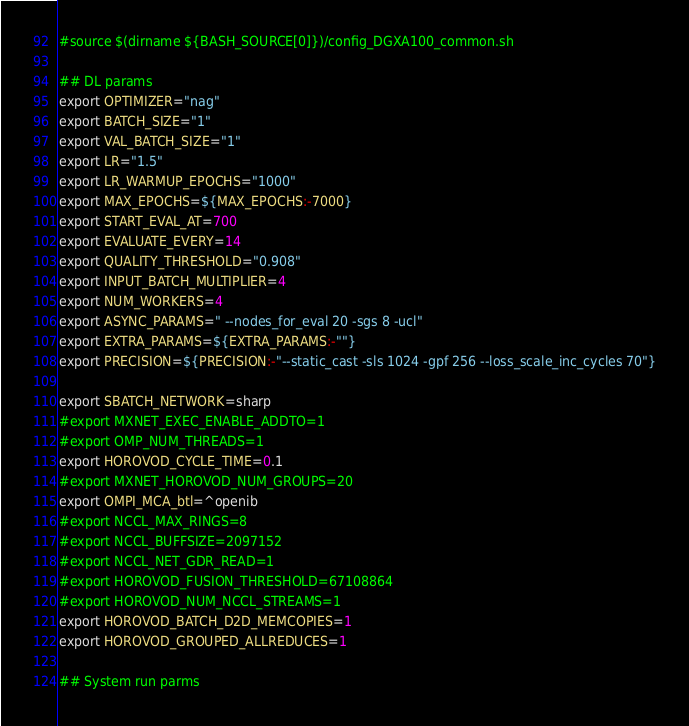<code> <loc_0><loc_0><loc_500><loc_500><_Bash_>#source $(dirname ${BASH_SOURCE[0]})/config_DGXA100_common.sh

## DL params
export OPTIMIZER="nag"
export BATCH_SIZE="1"
export VAL_BATCH_SIZE="1"
export LR="1.5"
export LR_WARMUP_EPOCHS="1000"
export MAX_EPOCHS=${MAX_EPOCHS:-7000}
export START_EVAL_AT=700
export EVALUATE_EVERY=14
export QUALITY_THRESHOLD="0.908"
export INPUT_BATCH_MULTIPLIER=4
export NUM_WORKERS=4
export ASYNC_PARAMS=" --nodes_for_eval 20 -sgs 8 -ucl"
export EXTRA_PARAMS=${EXTRA_PARAMS:-""}
export PRECISION=${PRECISION:-"--static_cast -sls 1024 -gpf 256 --loss_scale_inc_cycles 70"}

export SBATCH_NETWORK=sharp
#export MXNET_EXEC_ENABLE_ADDTO=1
#export OMP_NUM_THREADS=1
export HOROVOD_CYCLE_TIME=0.1
#export MXNET_HOROVOD_NUM_GROUPS=20
export OMPI_MCA_btl=^openib
#export NCCL_MAX_RINGS=8
#export NCCL_BUFFSIZE=2097152
#export NCCL_NET_GDR_READ=1
#export HOROVOD_FUSION_THRESHOLD=67108864
#export HOROVOD_NUM_NCCL_STREAMS=1
export HOROVOD_BATCH_D2D_MEMCOPIES=1
export HOROVOD_GROUPED_ALLREDUCES=1

## System run parms</code> 